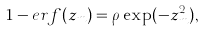Convert formula to latex. <formula><loc_0><loc_0><loc_500><loc_500>1 - e r f ( z _ { m } ) = \rho \exp ( - z _ { m } ^ { 2 } ) ,</formula> 